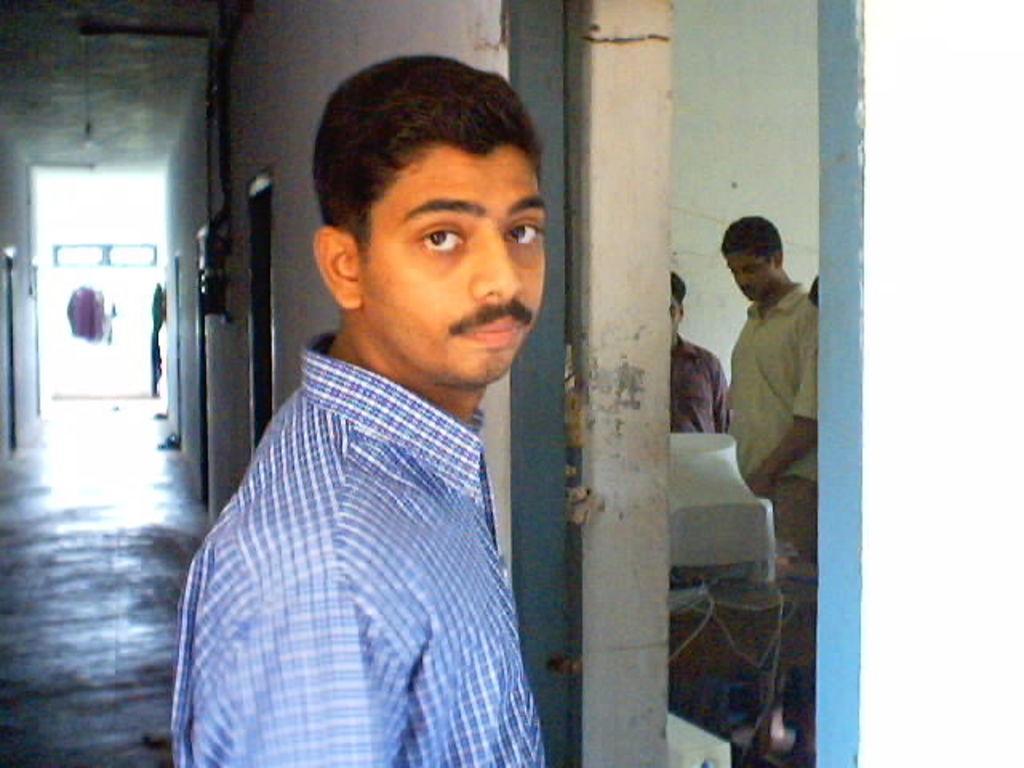Could you give a brief overview of what you see in this image? In this picture there is a boy, who is standing in the center of the image and there are other boys those who are standing in the room, on the right side of the image, there are doors on the left side of the image. 